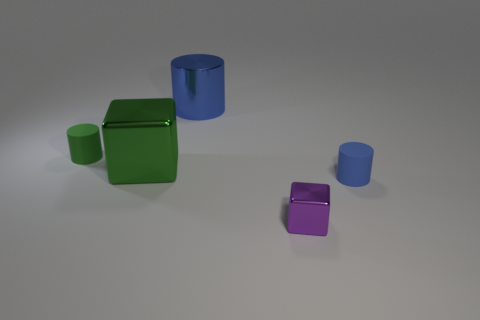Imagine this is a scene from a story. What narrative could be constructed around these objects? In a playful narrative, these objects could represent the characters in a tale of balance and structure. The green cube, with its unique position, could be the protagonist, always striving for a different perspective. The blue cylinders might be guardians of order, standing tall and unwavering, while the small purple cube could symbolize the underdog or the small but vital piece of a larger puzzle that everyone underestimates. Their positions and interactions create a story of harmony amid diversity. 